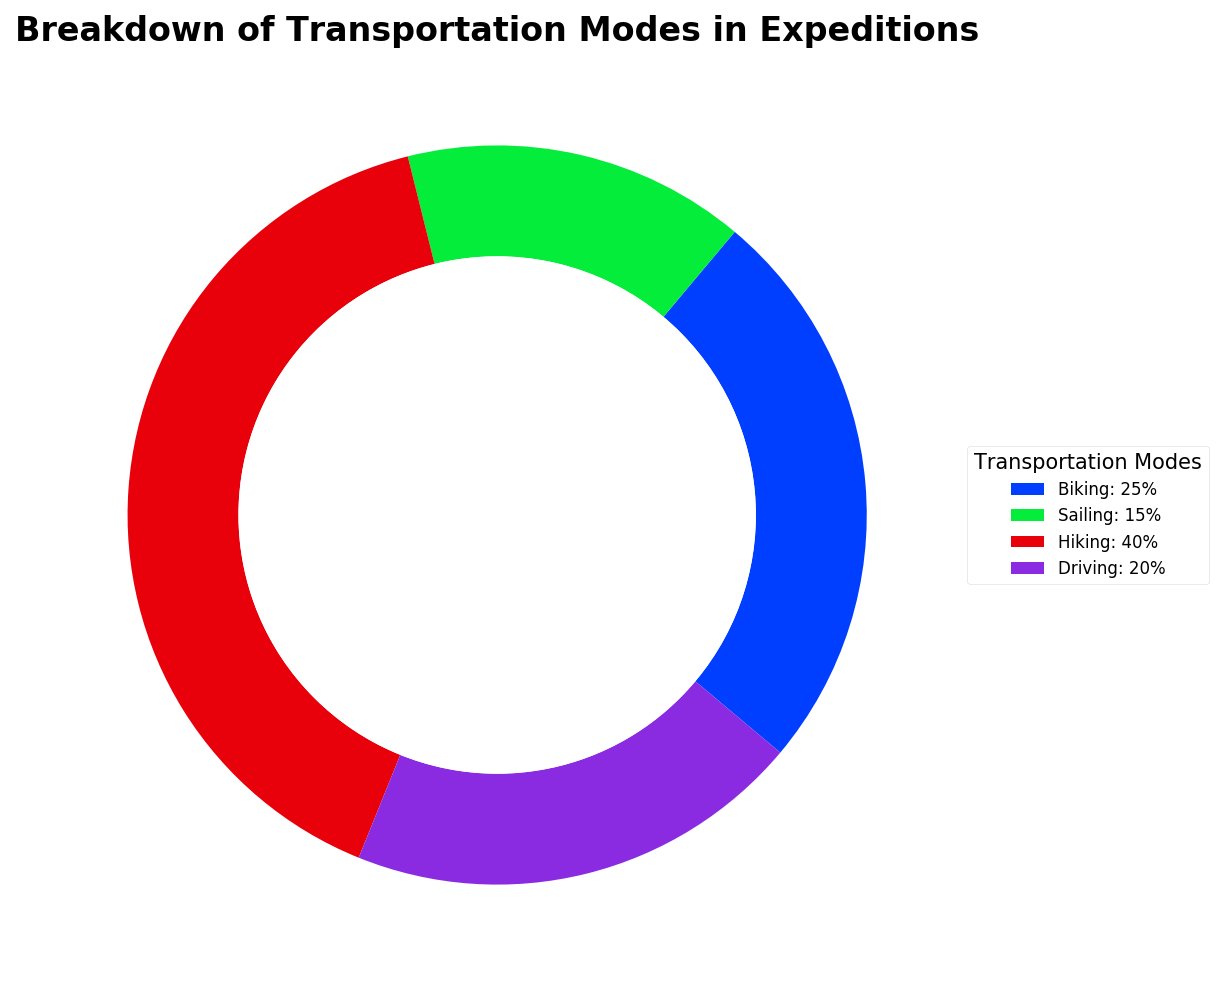Which transportation mode has the highest percentage? Hiking has the highest percentage as indicated by the largest segment in the ring chart.
Answer: Hiking Which transport mode has the smallest share in expeditions? Sailing has the smallest share as it occupies the smallest segment in the chart.
Answer: Sailing What is the combined percentage of Biking and Driving? Biking contributes 25% and Driving 20%, so combined they make up 25% + 20% = 45%.
Answer: 45% How does the percentage of Hiking compare to that of Driving? Hiking's 40% is higher than Driving's 20%, as can be visually confirmed by the larger segment Hiking occupies in the chart.
Answer: Hiking is higher Is there any mode that makes up exactly 20%? Yes, the ring chart shows that Driving makes up exactly 20%.
Answer: Driving If you were to equally distribute the total percentage among the modes, what would each percentage be and which modes would need an adjustment? There are 4 modes, so equal distribution would be 100/4 = 25% per mode. Driving (20%) and Sailing (15%) would need an increase, while Hiking (40%) would need a reduction. Biking already fits at 25%.
Answer: 25%, Driving and Sailing increase, Hiking reduce What is the total percentage of water-based transportation modes (Sailing)? Water-based transportation is only Sailing, which makes up 15% of the total.
Answer: 15% How much more percentage does Hiking contribute compared to Sailing? Hiking contributes 40%, while Sailing contributes 15%. The difference is 40% - 15% = 25%.
Answer: 25% Which two modes combined contribute just over half of the total percentage? Hiking and Biking combined contribute 40% + 25% = 65%, which is just over half.
Answer: Hiking and Biking 